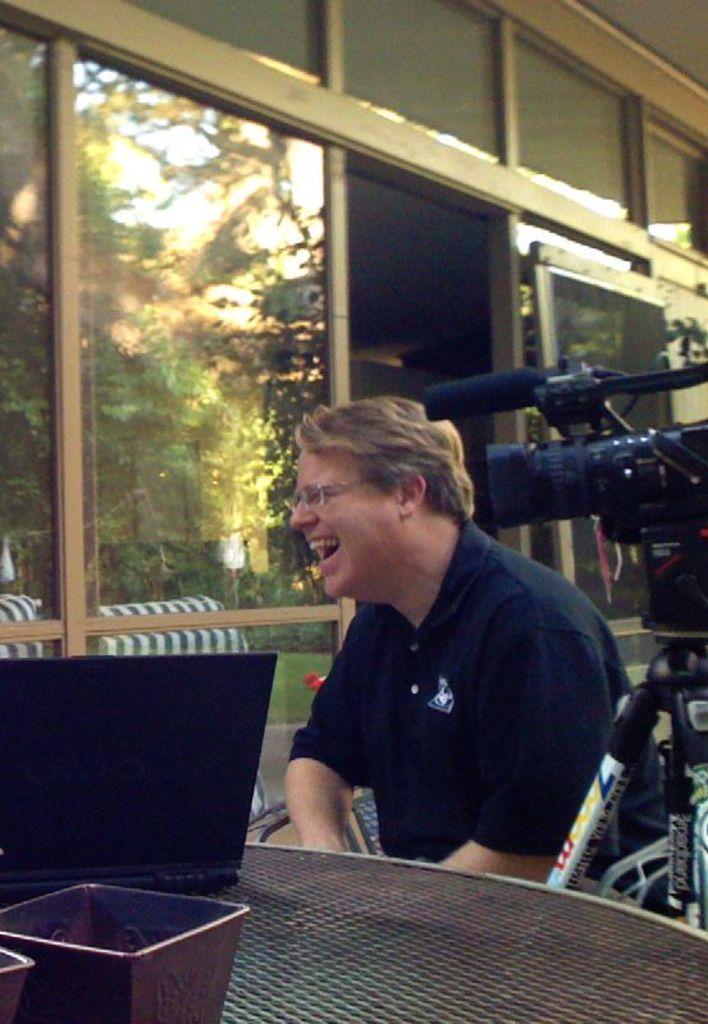Could you give a brief overview of what you see in this image? There is a person sitting on a chair. He is smiling and he has spectacles. Here we can see a table, laptop, bowl, and a camera. In the background we can see glasses, and trees. 